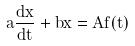Convert formula to latex. <formula><loc_0><loc_0><loc_500><loc_500>a \frac { d x } { d t } + b x = A f ( t )</formula> 